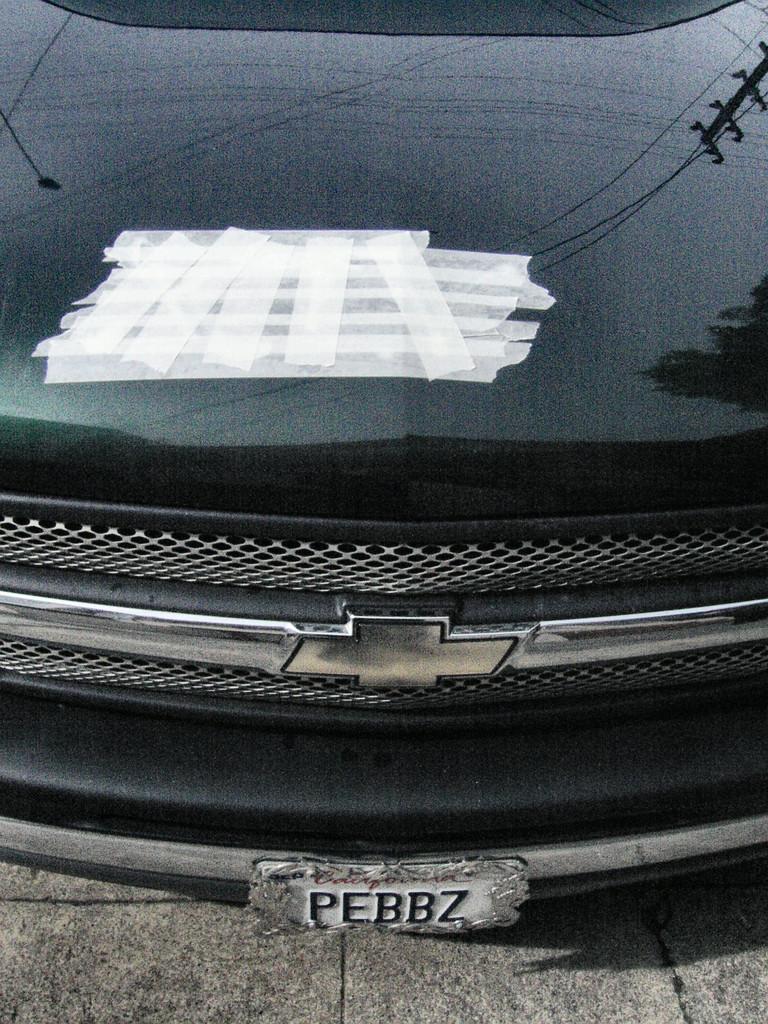Describe this image in one or two sentences. In this image I can see a car on the ground and few white plasters are attached to this car. 